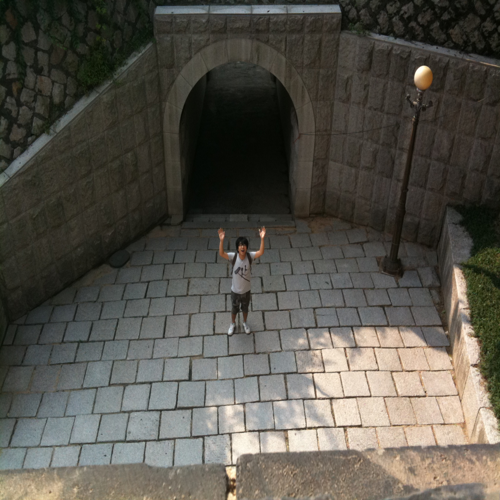What might be the purpose of this tunnel? This tunnel likely serves as a pedestrian passage, perhaps under a roadway or railway, to provide a safe route for individuals crossing from one side to the other. 